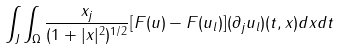<formula> <loc_0><loc_0><loc_500><loc_500>\int _ { J } \int _ { \Omega } \frac { x _ { j } } { ( 1 + | x | ^ { 2 } ) ^ { 1 / 2 } } [ F ( u ) - F ( u _ { l } ) ] ( \partial _ { j } u _ { l } ) ( t , x ) d x d t</formula> 